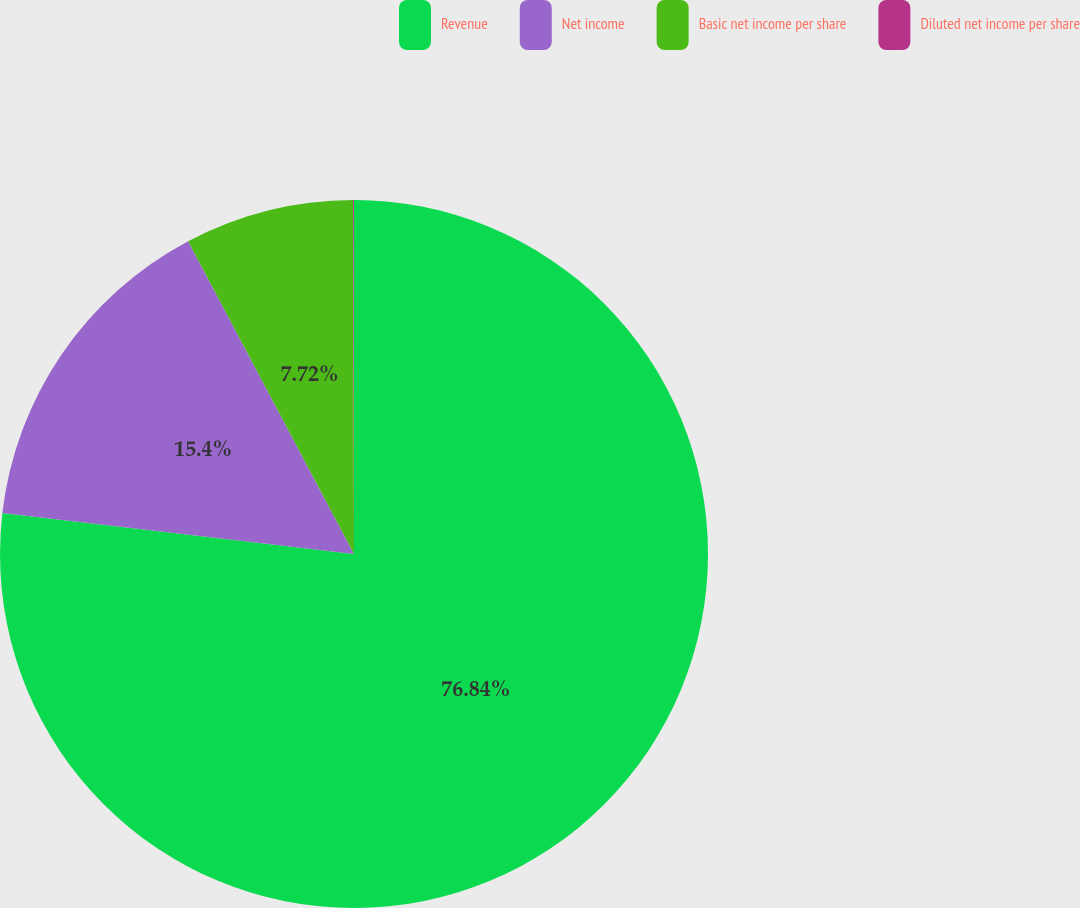Convert chart to OTSL. <chart><loc_0><loc_0><loc_500><loc_500><pie_chart><fcel>Revenue<fcel>Net income<fcel>Basic net income per share<fcel>Diluted net income per share<nl><fcel>76.85%<fcel>15.4%<fcel>7.72%<fcel>0.04%<nl></chart> 